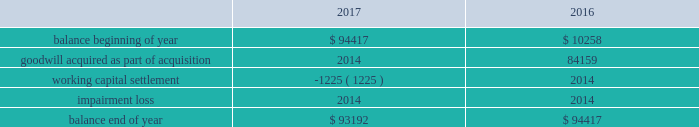Note 4 - goodwill and other intangible assets : goodwill the company had approximately $ 93.2 million and $ 94.4 million of goodwill at december 30 , 2017 and december 31 , 2016 , respectively .
The changes in the carrying amount of goodwill for the years ended december 30 , 2017 and december 31 , 2016 are as follows ( in thousands ) : .
Goodwill is allocated to each identified reporting unit , which is defined as an operating segment or one level below the operating segment .
Goodwill is not amortized , but is evaluated for impairment annually and whenever events or changes in circumstances indicate the carrying value of goodwill may not be recoverable .
The company completes its impairment evaluation by performing valuation analyses and considering other publicly available market information , as appropriate .
The test used to identify the potential for goodwill impairment compares the fair value of a reporting unit with its carrying value .
An impairment charge would be recorded to the company 2019s operations for the amount , if any , in which the carrying value exceeds the fair value .
In the fourth quarter of fiscal 2017 , the company completed its annual impairment testing of goodwill and no impairment was identified .
The company determined that the fair value of each reporting unit ( including goodwill ) was in excess of the carrying value of the respective reporting unit .
In reaching this conclusion , the fair value of each reporting unit was determined based on either a market or an income approach .
Under the market approach , the fair value is based on observed market data .
Other intangible assets the company had approximately $ 31.3 million of intangible assets other than goodwill at december 30 , 2017 and december 31 , 2016 .
The intangible asset balance represents the estimated fair value of the petsense tradename , which is not subject to amortization as it has an indefinite useful life on the basis that it is expected to contribute cash flows beyond the foreseeable horizon .
With respect to intangible assets , we evaluate for impairment annually and whenever events or changes in circumstances indicate that the carrying value may not be recoverable .
We recognize an impairment loss only if the carrying amount is not recoverable through its discounted cash flows and measure the impairment loss based on the difference between the carrying value and fair value .
In the fourth quarter of fiscal 2017 , the company completed its annual impairment testing of intangible assets and no impairment was identified. .
How much is the goodwill worth in 2016 if the intangible assets are worth $ 31.1 million? 
Rationale: in the first line , it says that the goodwill and intangibles assets for 2016 was $ 94.4 million this means that if the intangible assets was $ 31.3 million . therefore , the goodwill will be 63.1 million
Computations: (94.4 - 31.3)
Answer: 63.1. 